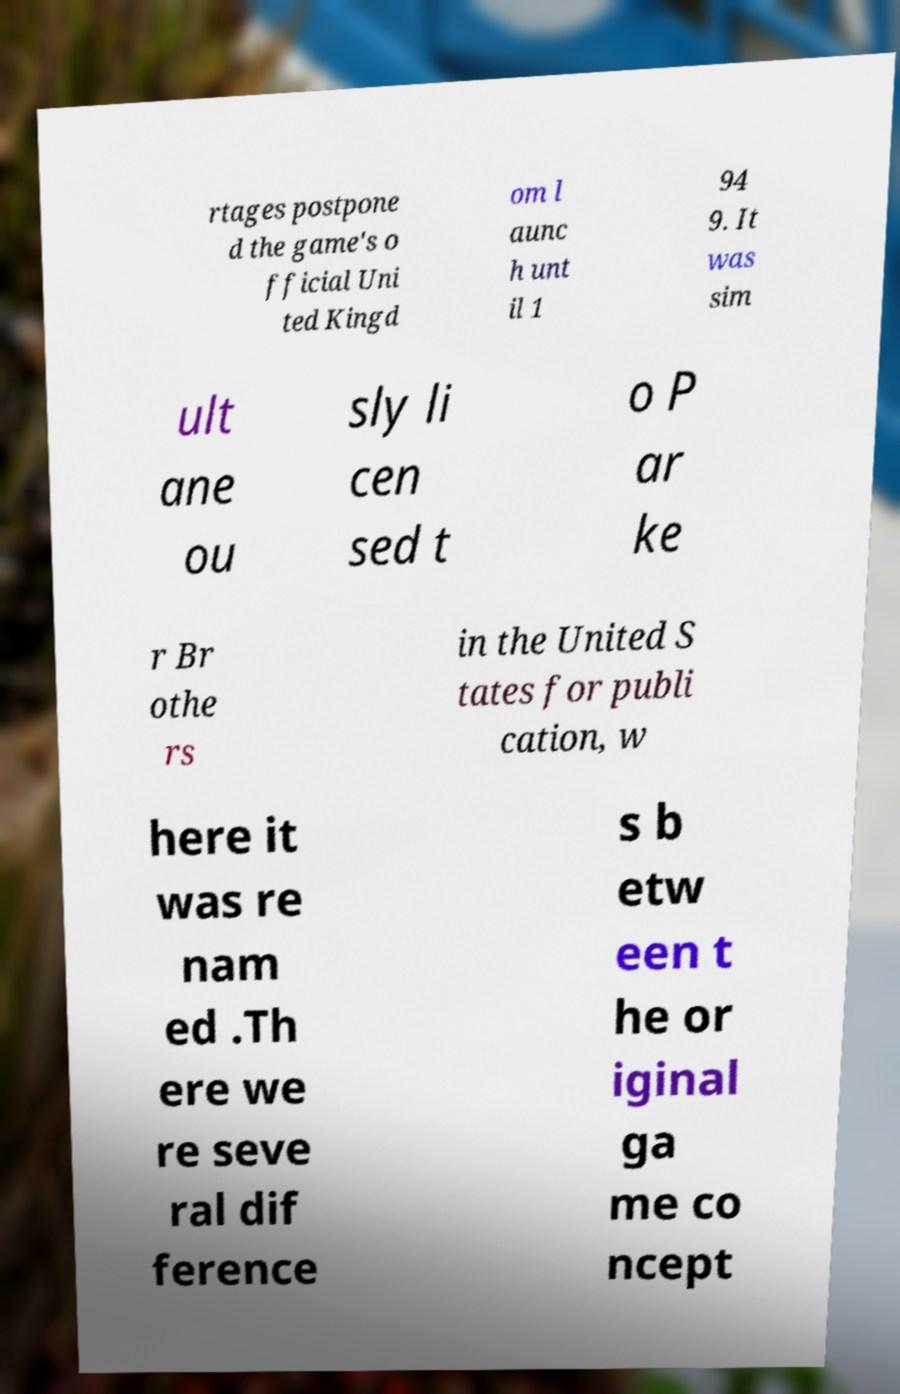What messages or text are displayed in this image? I need them in a readable, typed format. rtages postpone d the game's o fficial Uni ted Kingd om l aunc h unt il 1 94 9. It was sim ult ane ou sly li cen sed t o P ar ke r Br othe rs in the United S tates for publi cation, w here it was re nam ed .Th ere we re seve ral dif ference s b etw een t he or iginal ga me co ncept 